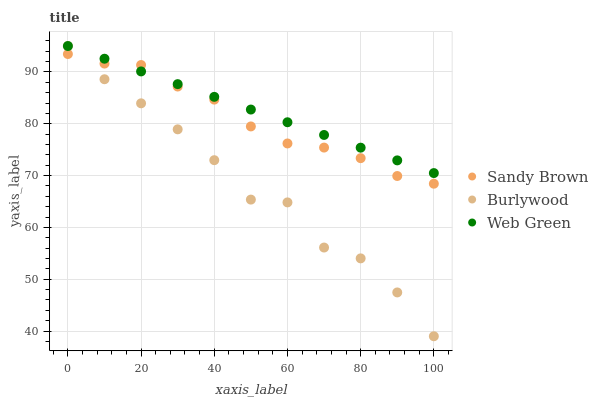Does Burlywood have the minimum area under the curve?
Answer yes or no. Yes. Does Web Green have the maximum area under the curve?
Answer yes or no. Yes. Does Sandy Brown have the minimum area under the curve?
Answer yes or no. No. Does Sandy Brown have the maximum area under the curve?
Answer yes or no. No. Is Web Green the smoothest?
Answer yes or no. Yes. Is Burlywood the roughest?
Answer yes or no. Yes. Is Sandy Brown the smoothest?
Answer yes or no. No. Is Sandy Brown the roughest?
Answer yes or no. No. Does Burlywood have the lowest value?
Answer yes or no. Yes. Does Sandy Brown have the lowest value?
Answer yes or no. No. Does Web Green have the highest value?
Answer yes or no. Yes. Does Sandy Brown have the highest value?
Answer yes or no. No. Does Web Green intersect Sandy Brown?
Answer yes or no. Yes. Is Web Green less than Sandy Brown?
Answer yes or no. No. Is Web Green greater than Sandy Brown?
Answer yes or no. No. 